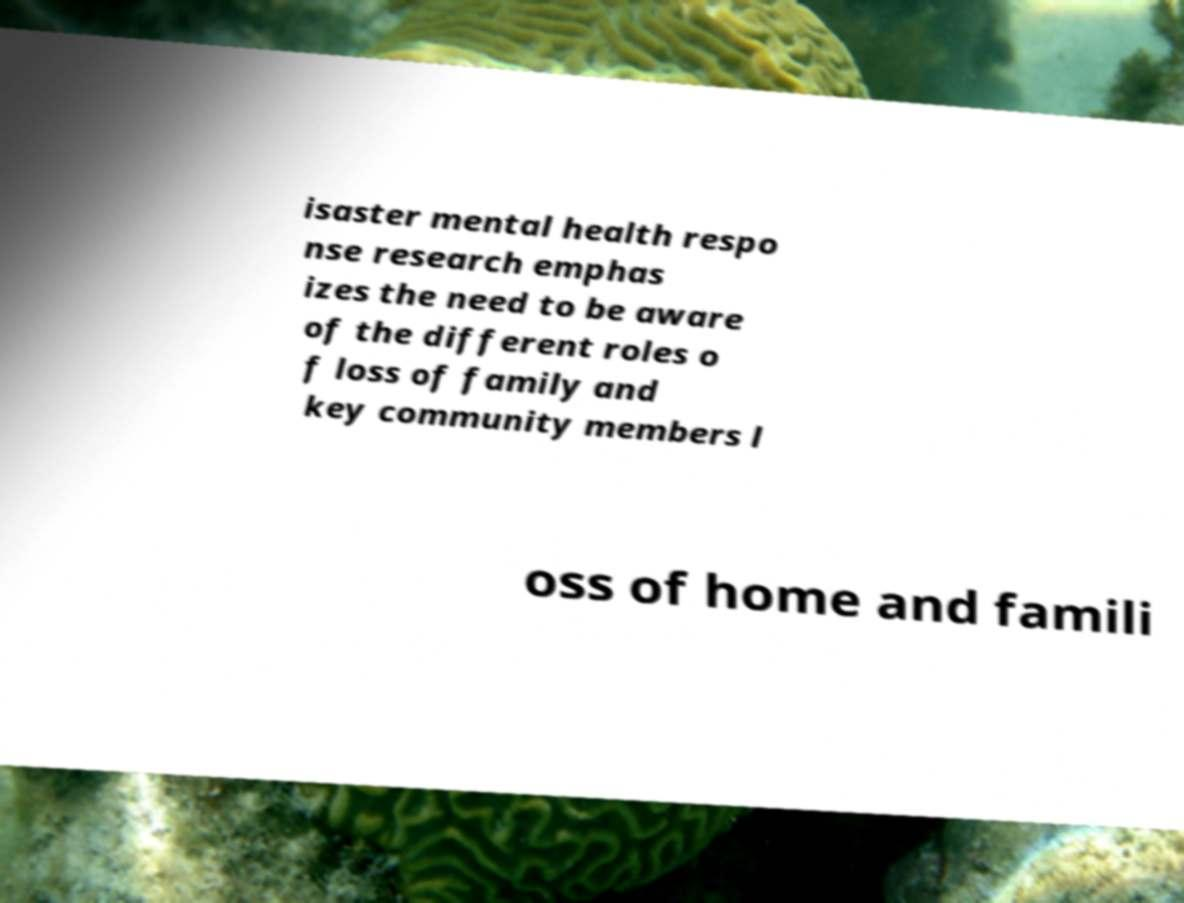Could you extract and type out the text from this image? isaster mental health respo nse research emphas izes the need to be aware of the different roles o f loss of family and key community members l oss of home and famili 